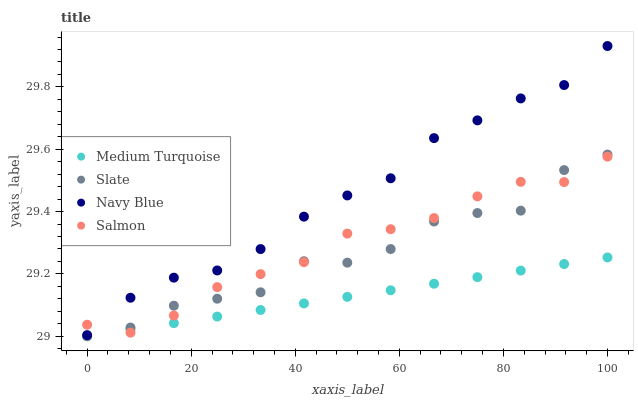Does Medium Turquoise have the minimum area under the curve?
Answer yes or no. Yes. Does Navy Blue have the maximum area under the curve?
Answer yes or no. Yes. Does Slate have the minimum area under the curve?
Answer yes or no. No. Does Slate have the maximum area under the curve?
Answer yes or no. No. Is Medium Turquoise the smoothest?
Answer yes or no. Yes. Is Slate the roughest?
Answer yes or no. Yes. Is Salmon the smoothest?
Answer yes or no. No. Is Salmon the roughest?
Answer yes or no. No. Does Slate have the lowest value?
Answer yes or no. Yes. Does Salmon have the lowest value?
Answer yes or no. No. Does Navy Blue have the highest value?
Answer yes or no. Yes. Does Slate have the highest value?
Answer yes or no. No. Is Slate less than Navy Blue?
Answer yes or no. Yes. Is Navy Blue greater than Medium Turquoise?
Answer yes or no. Yes. Does Navy Blue intersect Salmon?
Answer yes or no. Yes. Is Navy Blue less than Salmon?
Answer yes or no. No. Is Navy Blue greater than Salmon?
Answer yes or no. No. Does Slate intersect Navy Blue?
Answer yes or no. No. 